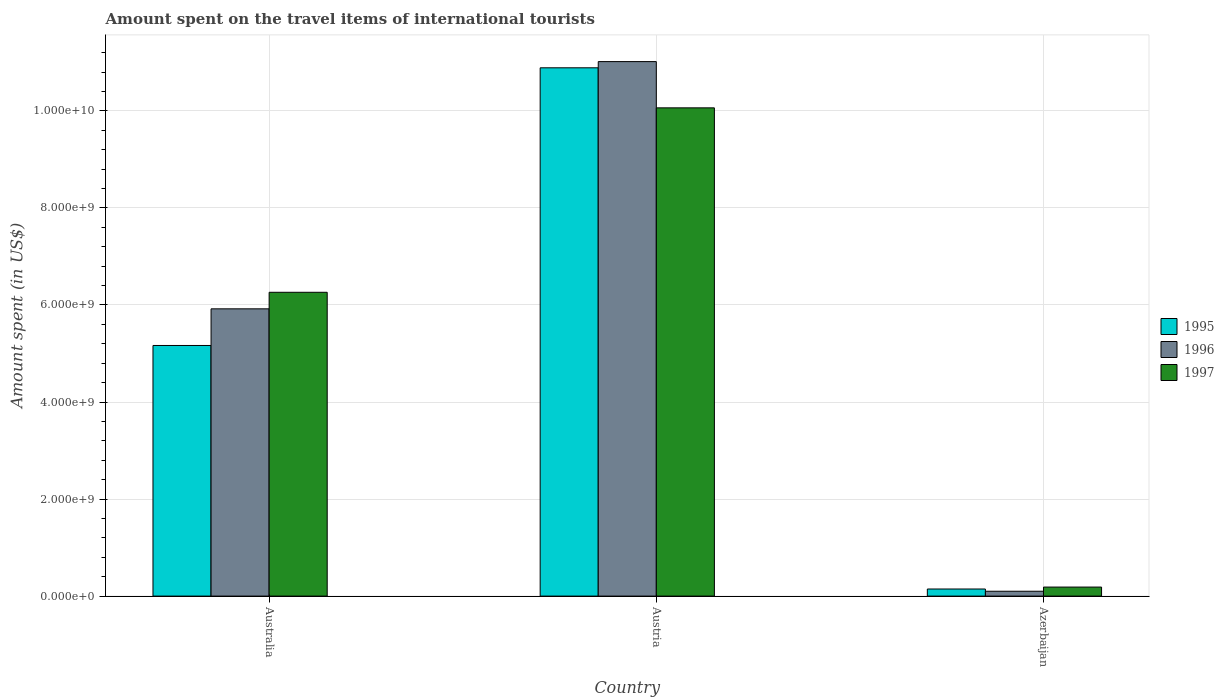How many different coloured bars are there?
Provide a short and direct response. 3. How many bars are there on the 3rd tick from the left?
Your answer should be compact. 3. What is the label of the 1st group of bars from the left?
Ensure brevity in your answer.  Australia. What is the amount spent on the travel items of international tourists in 1996 in Azerbaijan?
Keep it short and to the point. 1.00e+08. Across all countries, what is the maximum amount spent on the travel items of international tourists in 1995?
Provide a short and direct response. 1.09e+1. In which country was the amount spent on the travel items of international tourists in 1996 maximum?
Make the answer very short. Austria. In which country was the amount spent on the travel items of international tourists in 1997 minimum?
Provide a succinct answer. Azerbaijan. What is the total amount spent on the travel items of international tourists in 1995 in the graph?
Your response must be concise. 1.62e+1. What is the difference between the amount spent on the travel items of international tourists in 1995 in Australia and that in Azerbaijan?
Give a very brief answer. 5.02e+09. What is the difference between the amount spent on the travel items of international tourists in 1997 in Austria and the amount spent on the travel items of international tourists in 1995 in Azerbaijan?
Make the answer very short. 9.92e+09. What is the average amount spent on the travel items of international tourists in 1995 per country?
Give a very brief answer. 5.40e+09. What is the difference between the amount spent on the travel items of international tourists of/in 1997 and amount spent on the travel items of international tourists of/in 1996 in Australia?
Your answer should be very brief. 3.41e+08. In how many countries, is the amount spent on the travel items of international tourists in 1996 greater than 7200000000 US$?
Your answer should be compact. 1. What is the ratio of the amount spent on the travel items of international tourists in 1996 in Australia to that in Austria?
Provide a short and direct response. 0.54. Is the difference between the amount spent on the travel items of international tourists in 1997 in Austria and Azerbaijan greater than the difference between the amount spent on the travel items of international tourists in 1996 in Austria and Azerbaijan?
Keep it short and to the point. No. What is the difference between the highest and the second highest amount spent on the travel items of international tourists in 1995?
Your answer should be compact. 5.72e+09. What is the difference between the highest and the lowest amount spent on the travel items of international tourists in 1997?
Your answer should be very brief. 9.88e+09. Is the sum of the amount spent on the travel items of international tourists in 1996 in Australia and Azerbaijan greater than the maximum amount spent on the travel items of international tourists in 1997 across all countries?
Ensure brevity in your answer.  No. What does the 3rd bar from the left in Austria represents?
Your answer should be compact. 1997. How many bars are there?
Your answer should be compact. 9. Are all the bars in the graph horizontal?
Offer a terse response. No. How many countries are there in the graph?
Give a very brief answer. 3. What is the difference between two consecutive major ticks on the Y-axis?
Give a very brief answer. 2.00e+09. Does the graph contain grids?
Ensure brevity in your answer.  Yes. Where does the legend appear in the graph?
Offer a terse response. Center right. How are the legend labels stacked?
Give a very brief answer. Vertical. What is the title of the graph?
Your answer should be very brief. Amount spent on the travel items of international tourists. What is the label or title of the X-axis?
Your response must be concise. Country. What is the label or title of the Y-axis?
Offer a very short reply. Amount spent (in US$). What is the Amount spent (in US$) in 1995 in Australia?
Your answer should be very brief. 5.16e+09. What is the Amount spent (in US$) in 1996 in Australia?
Ensure brevity in your answer.  5.92e+09. What is the Amount spent (in US$) of 1997 in Australia?
Provide a succinct answer. 6.26e+09. What is the Amount spent (in US$) of 1995 in Austria?
Keep it short and to the point. 1.09e+1. What is the Amount spent (in US$) of 1996 in Austria?
Give a very brief answer. 1.10e+1. What is the Amount spent (in US$) of 1997 in Austria?
Offer a very short reply. 1.01e+1. What is the Amount spent (in US$) in 1995 in Azerbaijan?
Make the answer very short. 1.46e+08. What is the Amount spent (in US$) of 1997 in Azerbaijan?
Offer a very short reply. 1.86e+08. Across all countries, what is the maximum Amount spent (in US$) in 1995?
Offer a terse response. 1.09e+1. Across all countries, what is the maximum Amount spent (in US$) in 1996?
Make the answer very short. 1.10e+1. Across all countries, what is the maximum Amount spent (in US$) of 1997?
Ensure brevity in your answer.  1.01e+1. Across all countries, what is the minimum Amount spent (in US$) in 1995?
Offer a terse response. 1.46e+08. Across all countries, what is the minimum Amount spent (in US$) of 1997?
Your answer should be very brief. 1.86e+08. What is the total Amount spent (in US$) in 1995 in the graph?
Give a very brief answer. 1.62e+1. What is the total Amount spent (in US$) in 1996 in the graph?
Provide a short and direct response. 1.70e+1. What is the total Amount spent (in US$) of 1997 in the graph?
Offer a very short reply. 1.65e+1. What is the difference between the Amount spent (in US$) of 1995 in Australia and that in Austria?
Your answer should be very brief. -5.72e+09. What is the difference between the Amount spent (in US$) in 1996 in Australia and that in Austria?
Your answer should be compact. -5.10e+09. What is the difference between the Amount spent (in US$) in 1997 in Australia and that in Austria?
Offer a very short reply. -3.80e+09. What is the difference between the Amount spent (in US$) in 1995 in Australia and that in Azerbaijan?
Keep it short and to the point. 5.02e+09. What is the difference between the Amount spent (in US$) in 1996 in Australia and that in Azerbaijan?
Ensure brevity in your answer.  5.82e+09. What is the difference between the Amount spent (in US$) of 1997 in Australia and that in Azerbaijan?
Provide a succinct answer. 6.08e+09. What is the difference between the Amount spent (in US$) of 1995 in Austria and that in Azerbaijan?
Offer a terse response. 1.07e+1. What is the difference between the Amount spent (in US$) of 1996 in Austria and that in Azerbaijan?
Provide a succinct answer. 1.09e+1. What is the difference between the Amount spent (in US$) in 1997 in Austria and that in Azerbaijan?
Make the answer very short. 9.88e+09. What is the difference between the Amount spent (in US$) of 1995 in Australia and the Amount spent (in US$) of 1996 in Austria?
Offer a very short reply. -5.85e+09. What is the difference between the Amount spent (in US$) in 1995 in Australia and the Amount spent (in US$) in 1997 in Austria?
Your response must be concise. -4.90e+09. What is the difference between the Amount spent (in US$) in 1996 in Australia and the Amount spent (in US$) in 1997 in Austria?
Provide a short and direct response. -4.14e+09. What is the difference between the Amount spent (in US$) in 1995 in Australia and the Amount spent (in US$) in 1996 in Azerbaijan?
Keep it short and to the point. 5.06e+09. What is the difference between the Amount spent (in US$) of 1995 in Australia and the Amount spent (in US$) of 1997 in Azerbaijan?
Keep it short and to the point. 4.98e+09. What is the difference between the Amount spent (in US$) in 1996 in Australia and the Amount spent (in US$) in 1997 in Azerbaijan?
Make the answer very short. 5.73e+09. What is the difference between the Amount spent (in US$) of 1995 in Austria and the Amount spent (in US$) of 1996 in Azerbaijan?
Ensure brevity in your answer.  1.08e+1. What is the difference between the Amount spent (in US$) of 1995 in Austria and the Amount spent (in US$) of 1997 in Azerbaijan?
Offer a terse response. 1.07e+1. What is the difference between the Amount spent (in US$) in 1996 in Austria and the Amount spent (in US$) in 1997 in Azerbaijan?
Offer a very short reply. 1.08e+1. What is the average Amount spent (in US$) of 1995 per country?
Keep it short and to the point. 5.40e+09. What is the average Amount spent (in US$) in 1996 per country?
Make the answer very short. 5.68e+09. What is the average Amount spent (in US$) in 1997 per country?
Provide a short and direct response. 5.50e+09. What is the difference between the Amount spent (in US$) of 1995 and Amount spent (in US$) of 1996 in Australia?
Your response must be concise. -7.55e+08. What is the difference between the Amount spent (in US$) in 1995 and Amount spent (in US$) in 1997 in Australia?
Your response must be concise. -1.10e+09. What is the difference between the Amount spent (in US$) of 1996 and Amount spent (in US$) of 1997 in Australia?
Ensure brevity in your answer.  -3.41e+08. What is the difference between the Amount spent (in US$) in 1995 and Amount spent (in US$) in 1996 in Austria?
Your answer should be compact. -1.28e+08. What is the difference between the Amount spent (in US$) of 1995 and Amount spent (in US$) of 1997 in Austria?
Provide a succinct answer. 8.25e+08. What is the difference between the Amount spent (in US$) in 1996 and Amount spent (in US$) in 1997 in Austria?
Provide a succinct answer. 9.53e+08. What is the difference between the Amount spent (in US$) in 1995 and Amount spent (in US$) in 1996 in Azerbaijan?
Offer a terse response. 4.60e+07. What is the difference between the Amount spent (in US$) in 1995 and Amount spent (in US$) in 1997 in Azerbaijan?
Your response must be concise. -4.00e+07. What is the difference between the Amount spent (in US$) in 1996 and Amount spent (in US$) in 1997 in Azerbaijan?
Offer a terse response. -8.60e+07. What is the ratio of the Amount spent (in US$) in 1995 in Australia to that in Austria?
Provide a succinct answer. 0.47. What is the ratio of the Amount spent (in US$) of 1996 in Australia to that in Austria?
Provide a succinct answer. 0.54. What is the ratio of the Amount spent (in US$) in 1997 in Australia to that in Austria?
Make the answer very short. 0.62. What is the ratio of the Amount spent (in US$) of 1995 in Australia to that in Azerbaijan?
Your answer should be compact. 35.38. What is the ratio of the Amount spent (in US$) of 1996 in Australia to that in Azerbaijan?
Keep it short and to the point. 59.2. What is the ratio of the Amount spent (in US$) of 1997 in Australia to that in Azerbaijan?
Keep it short and to the point. 33.66. What is the ratio of the Amount spent (in US$) of 1995 in Austria to that in Azerbaijan?
Offer a very short reply. 74.57. What is the ratio of the Amount spent (in US$) of 1996 in Austria to that in Azerbaijan?
Give a very brief answer. 110.15. What is the ratio of the Amount spent (in US$) of 1997 in Austria to that in Azerbaijan?
Your answer should be compact. 54.1. What is the difference between the highest and the second highest Amount spent (in US$) in 1995?
Make the answer very short. 5.72e+09. What is the difference between the highest and the second highest Amount spent (in US$) in 1996?
Your response must be concise. 5.10e+09. What is the difference between the highest and the second highest Amount spent (in US$) in 1997?
Offer a terse response. 3.80e+09. What is the difference between the highest and the lowest Amount spent (in US$) in 1995?
Keep it short and to the point. 1.07e+1. What is the difference between the highest and the lowest Amount spent (in US$) of 1996?
Give a very brief answer. 1.09e+1. What is the difference between the highest and the lowest Amount spent (in US$) in 1997?
Ensure brevity in your answer.  9.88e+09. 